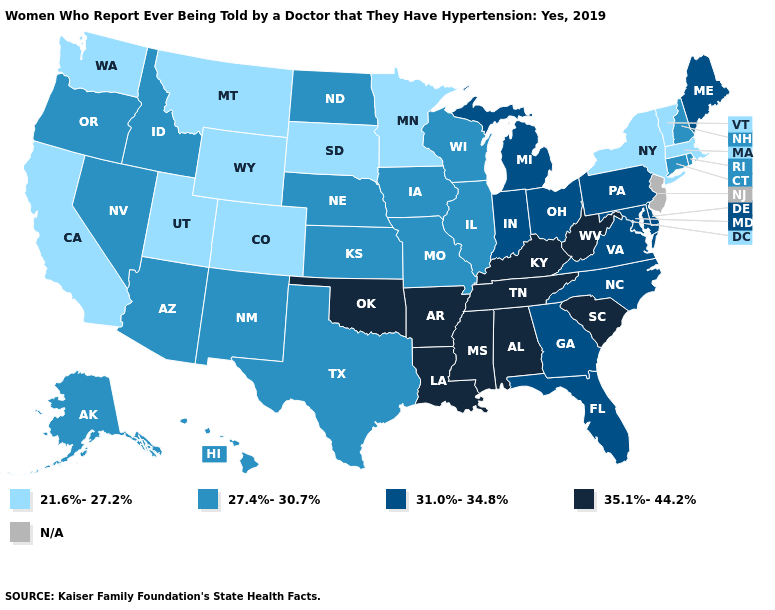Name the states that have a value in the range 27.4%-30.7%?
Give a very brief answer. Alaska, Arizona, Connecticut, Hawaii, Idaho, Illinois, Iowa, Kansas, Missouri, Nebraska, Nevada, New Hampshire, New Mexico, North Dakota, Oregon, Rhode Island, Texas, Wisconsin. How many symbols are there in the legend?
Be succinct. 5. Among the states that border Iowa , which have the highest value?
Short answer required. Illinois, Missouri, Nebraska, Wisconsin. Name the states that have a value in the range 35.1%-44.2%?
Answer briefly. Alabama, Arkansas, Kentucky, Louisiana, Mississippi, Oklahoma, South Carolina, Tennessee, West Virginia. What is the lowest value in the USA?
Answer briefly. 21.6%-27.2%. What is the value of Virginia?
Write a very short answer. 31.0%-34.8%. What is the value of Connecticut?
Write a very short answer. 27.4%-30.7%. Among the states that border Tennessee , does Kentucky have the highest value?
Quick response, please. Yes. How many symbols are there in the legend?
Write a very short answer. 5. What is the value of North Carolina?
Quick response, please. 31.0%-34.8%. Among the states that border Texas , does New Mexico have the highest value?
Short answer required. No. What is the value of Kentucky?
Quick response, please. 35.1%-44.2%. Name the states that have a value in the range N/A?
Write a very short answer. New Jersey. What is the value of Indiana?
Keep it brief. 31.0%-34.8%. What is the highest value in the West ?
Answer briefly. 27.4%-30.7%. 